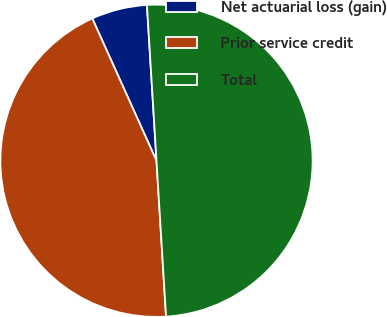<chart> <loc_0><loc_0><loc_500><loc_500><pie_chart><fcel>Net actuarial loss (gain)<fcel>Prior service credit<fcel>Total<nl><fcel>5.77%<fcel>44.23%<fcel>50.0%<nl></chart> 